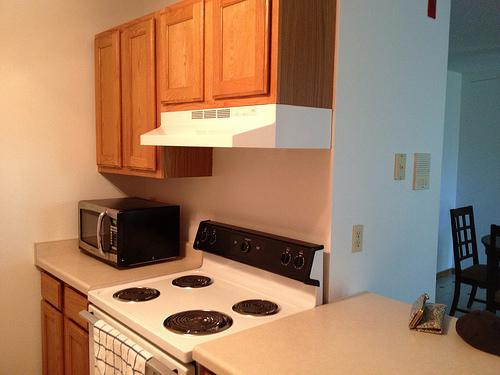Question: when is the kitchen light on?
Choices:
A. When it gets dark.
B. When the cook is in the kitchen.
C. It always stays on.
D. Now.
Answer with the letter. Answer: D Question: how many towels are there?
Choices:
A. Two.
B. Three.
C. One.
D. Four.
Answer with the letter. Answer: C Question: where is the stove?
Choices:
A. Camper.
B. Garage.
C. Kitchen.
D. Restaurant.
Answer with the letter. Answer: C Question: why is there a microwave?
Choices:
A. The family likes them.
B. The cook wanted one.
C. Fast cooking.
D. To heat up food.
Answer with the letter. Answer: C Question: what are the cabinets made of?
Choices:
A. Wood.
B. Plastic.
C. Metal.
D. Wicker.
Answer with the letter. Answer: A 